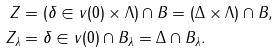Convert formula to latex. <formula><loc_0><loc_0><loc_500><loc_500>Z & = ( \delta \in v ( 0 ) \times \Lambda ) \cap B = ( \Delta \times \Lambda ) \cap B , \\ Z _ { \lambda } & = \delta \in v ( 0 ) \cap B _ { \lambda } = \Delta \cap B _ { \lambda } .</formula> 